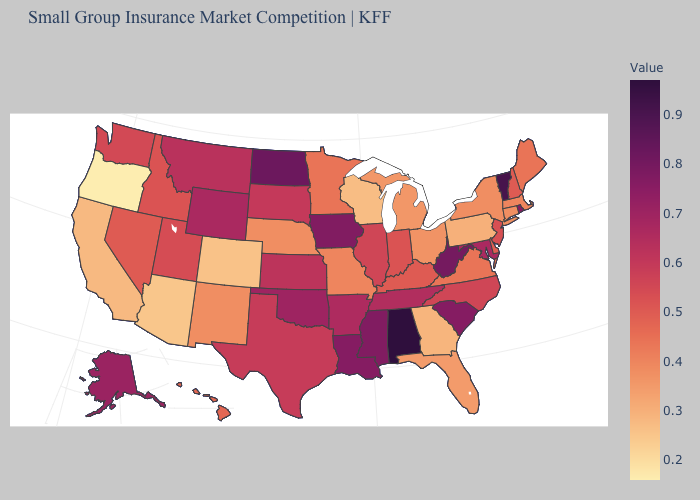Which states have the lowest value in the USA?
Short answer required. Oregon. Which states have the lowest value in the West?
Give a very brief answer. Oregon. Among the states that border Utah , which have the highest value?
Give a very brief answer. Wyoming. Among the states that border Florida , which have the highest value?
Quick response, please. Alabama. Does Wisconsin have the highest value in the MidWest?
Give a very brief answer. No. 